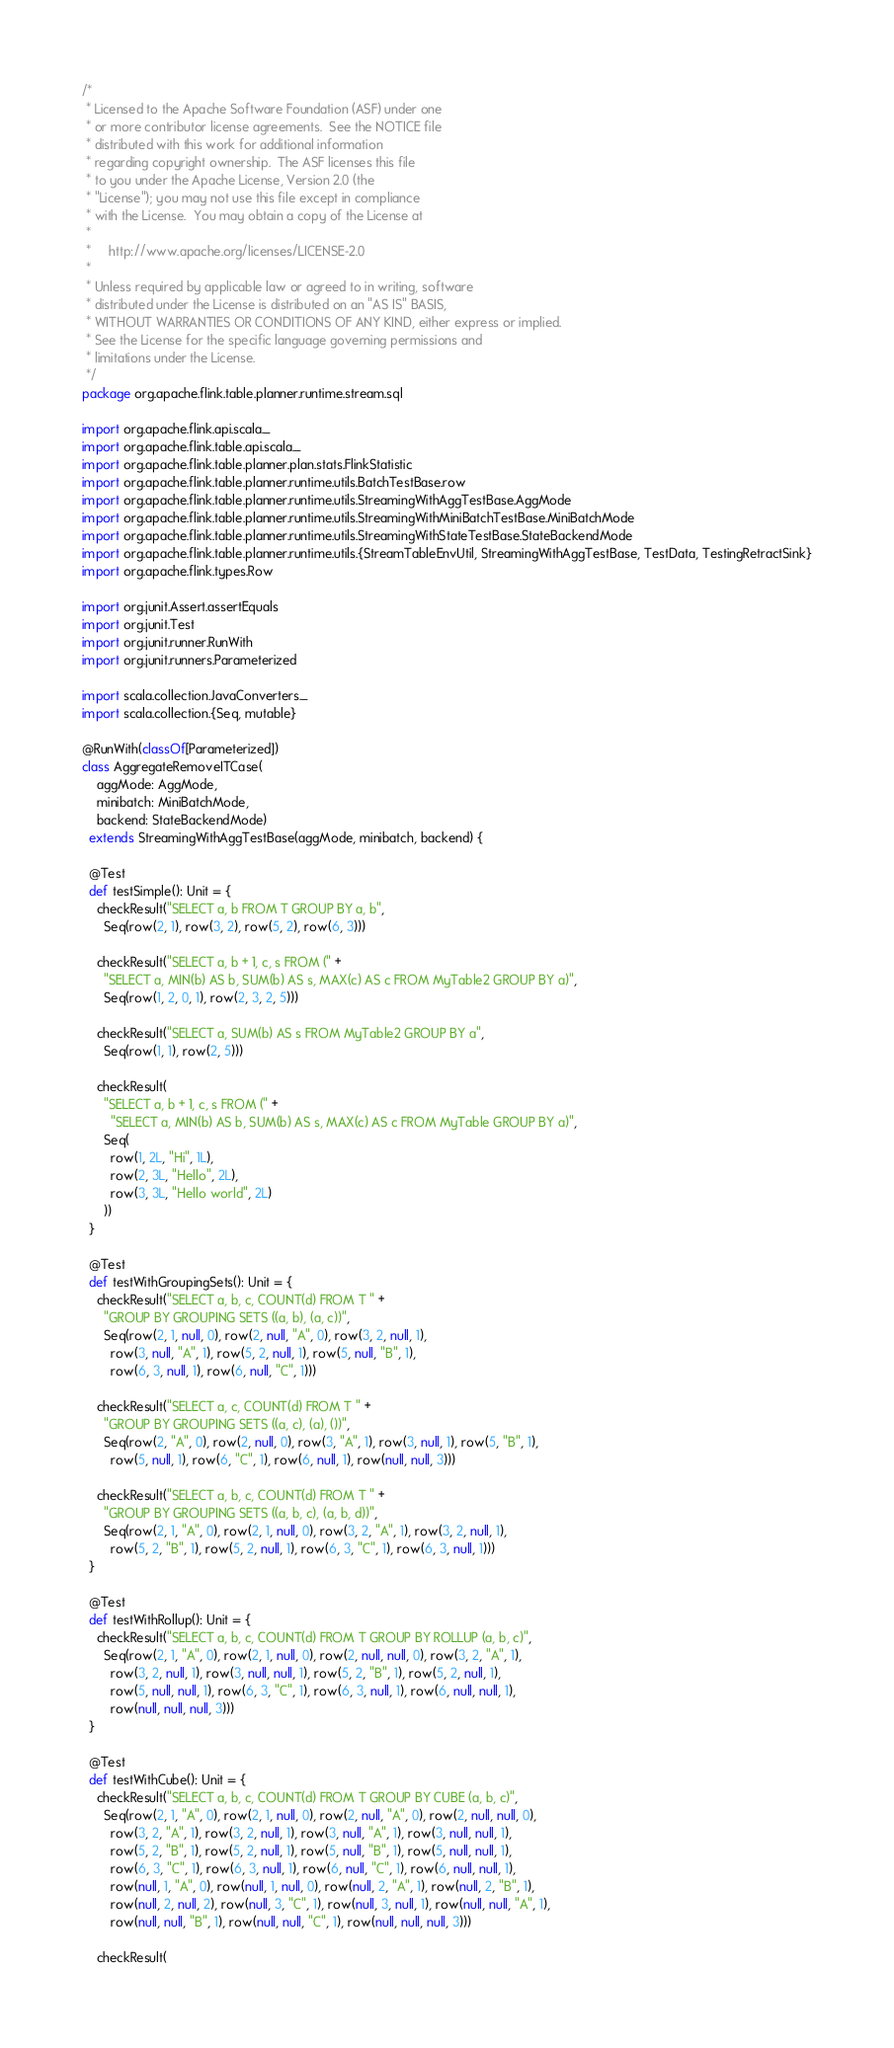<code> <loc_0><loc_0><loc_500><loc_500><_Scala_>/*
 * Licensed to the Apache Software Foundation (ASF) under one
 * or more contributor license agreements.  See the NOTICE file
 * distributed with this work for additional information
 * regarding copyright ownership.  The ASF licenses this file
 * to you under the Apache License, Version 2.0 (the
 * "License"); you may not use this file except in compliance
 * with the License.  You may obtain a copy of the License at
 *
 *     http://www.apache.org/licenses/LICENSE-2.0
 *
 * Unless required by applicable law or agreed to in writing, software
 * distributed under the License is distributed on an "AS IS" BASIS,
 * WITHOUT WARRANTIES OR CONDITIONS OF ANY KIND, either express or implied.
 * See the License for the specific language governing permissions and
 * limitations under the License.
 */
package org.apache.flink.table.planner.runtime.stream.sql

import org.apache.flink.api.scala._
import org.apache.flink.table.api.scala._
import org.apache.flink.table.planner.plan.stats.FlinkStatistic
import org.apache.flink.table.planner.runtime.utils.BatchTestBase.row
import org.apache.flink.table.planner.runtime.utils.StreamingWithAggTestBase.AggMode
import org.apache.flink.table.planner.runtime.utils.StreamingWithMiniBatchTestBase.MiniBatchMode
import org.apache.flink.table.planner.runtime.utils.StreamingWithStateTestBase.StateBackendMode
import org.apache.flink.table.planner.runtime.utils.{StreamTableEnvUtil, StreamingWithAggTestBase, TestData, TestingRetractSink}
import org.apache.flink.types.Row

import org.junit.Assert.assertEquals
import org.junit.Test
import org.junit.runner.RunWith
import org.junit.runners.Parameterized

import scala.collection.JavaConverters._
import scala.collection.{Seq, mutable}

@RunWith(classOf[Parameterized])
class AggregateRemoveITCase(
    aggMode: AggMode,
    minibatch: MiniBatchMode,
    backend: StateBackendMode)
  extends StreamingWithAggTestBase(aggMode, minibatch, backend) {

  @Test
  def testSimple(): Unit = {
    checkResult("SELECT a, b FROM T GROUP BY a, b",
      Seq(row(2, 1), row(3, 2), row(5, 2), row(6, 3)))

    checkResult("SELECT a, b + 1, c, s FROM (" +
      "SELECT a, MIN(b) AS b, SUM(b) AS s, MAX(c) AS c FROM MyTable2 GROUP BY a)",
      Seq(row(1, 2, 0, 1), row(2, 3, 2, 5)))

    checkResult("SELECT a, SUM(b) AS s FROM MyTable2 GROUP BY a",
      Seq(row(1, 1), row(2, 5)))

    checkResult(
      "SELECT a, b + 1, c, s FROM (" +
        "SELECT a, MIN(b) AS b, SUM(b) AS s, MAX(c) AS c FROM MyTable GROUP BY a)",
      Seq(
        row(1, 2L, "Hi", 1L),
        row(2, 3L, "Hello", 2L),
        row(3, 3L, "Hello world", 2L)
      ))
  }

  @Test
  def testWithGroupingSets(): Unit = {
    checkResult("SELECT a, b, c, COUNT(d) FROM T " +
      "GROUP BY GROUPING SETS ((a, b), (a, c))",
      Seq(row(2, 1, null, 0), row(2, null, "A", 0), row(3, 2, null, 1),
        row(3, null, "A", 1), row(5, 2, null, 1), row(5, null, "B", 1),
        row(6, 3, null, 1), row(6, null, "C", 1)))

    checkResult("SELECT a, c, COUNT(d) FROM T " +
      "GROUP BY GROUPING SETS ((a, c), (a), ())",
      Seq(row(2, "A", 0), row(2, null, 0), row(3, "A", 1), row(3, null, 1), row(5, "B", 1),
        row(5, null, 1), row(6, "C", 1), row(6, null, 1), row(null, null, 3)))

    checkResult("SELECT a, b, c, COUNT(d) FROM T " +
      "GROUP BY GROUPING SETS ((a, b, c), (a, b, d))",
      Seq(row(2, 1, "A", 0), row(2, 1, null, 0), row(3, 2, "A", 1), row(3, 2, null, 1),
        row(5, 2, "B", 1), row(5, 2, null, 1), row(6, 3, "C", 1), row(6, 3, null, 1)))
  }

  @Test
  def testWithRollup(): Unit = {
    checkResult("SELECT a, b, c, COUNT(d) FROM T GROUP BY ROLLUP (a, b, c)",
      Seq(row(2, 1, "A", 0), row(2, 1, null, 0), row(2, null, null, 0), row(3, 2, "A", 1),
        row(3, 2, null, 1), row(3, null, null, 1), row(5, 2, "B", 1), row(5, 2, null, 1),
        row(5, null, null, 1), row(6, 3, "C", 1), row(6, 3, null, 1), row(6, null, null, 1),
        row(null, null, null, 3)))
  }

  @Test
  def testWithCube(): Unit = {
    checkResult("SELECT a, b, c, COUNT(d) FROM T GROUP BY CUBE (a, b, c)",
      Seq(row(2, 1, "A", 0), row(2, 1, null, 0), row(2, null, "A", 0), row(2, null, null, 0),
        row(3, 2, "A", 1), row(3, 2, null, 1), row(3, null, "A", 1), row(3, null, null, 1),
        row(5, 2, "B", 1), row(5, 2, null, 1), row(5, null, "B", 1), row(5, null, null, 1),
        row(6, 3, "C", 1), row(6, 3, null, 1), row(6, null, "C", 1), row(6, null, null, 1),
        row(null, 1, "A", 0), row(null, 1, null, 0), row(null, 2, "A", 1), row(null, 2, "B", 1),
        row(null, 2, null, 2), row(null, 3, "C", 1), row(null, 3, null, 1), row(null, null, "A", 1),
        row(null, null, "B", 1), row(null, null, "C", 1), row(null, null, null, 3)))

    checkResult(</code> 